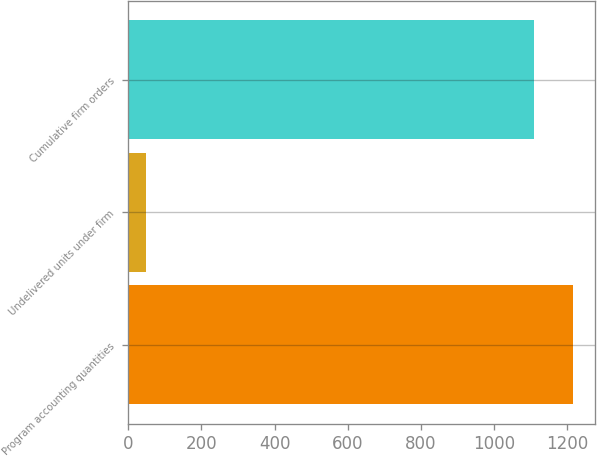Convert chart to OTSL. <chart><loc_0><loc_0><loc_500><loc_500><bar_chart><fcel>Program accounting quantities<fcel>Undelivered units under firm<fcel>Cumulative firm orders<nl><fcel>1216.4<fcel>49<fcel>1110<nl></chart> 